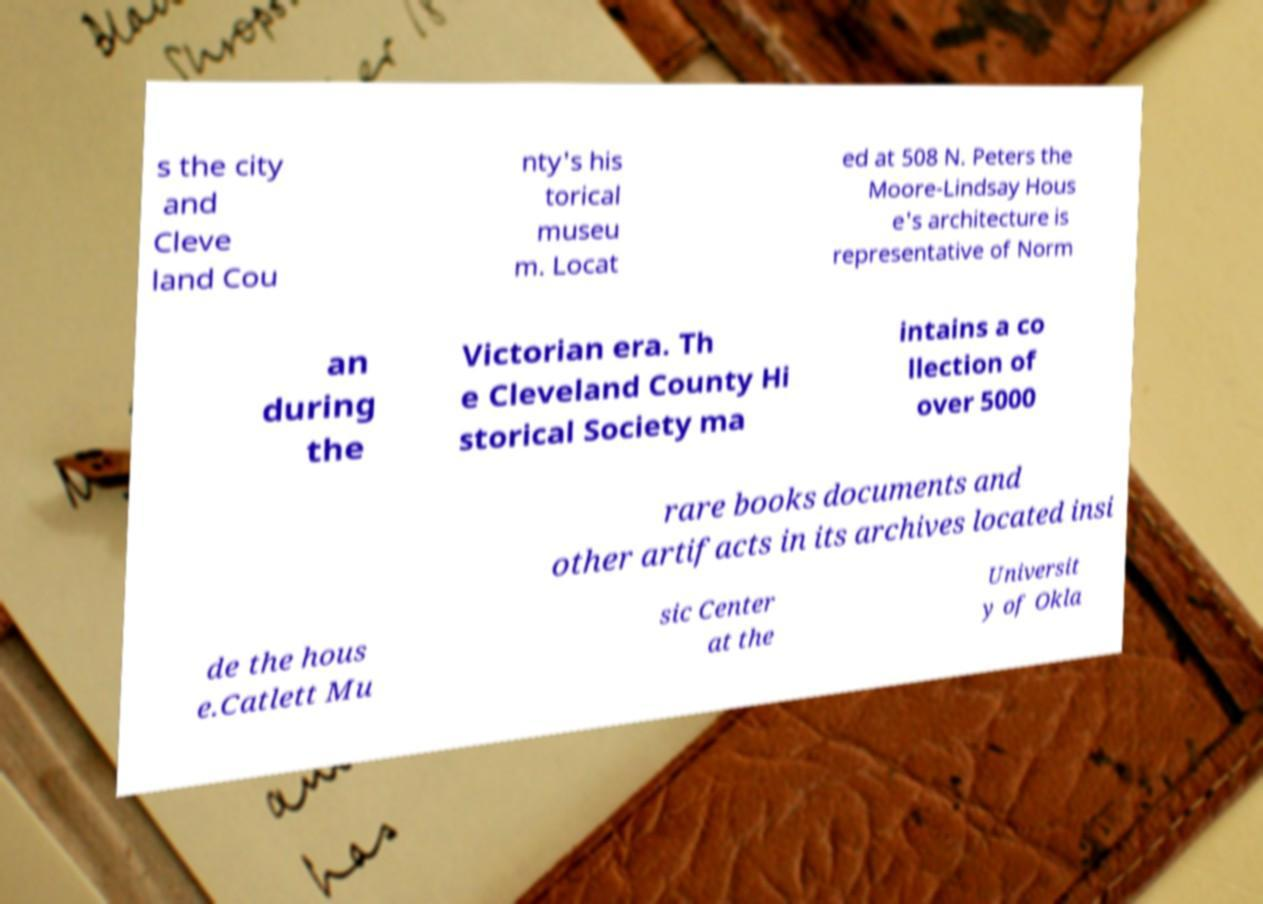Please read and relay the text visible in this image. What does it say? s the city and Cleve land Cou nty's his torical museu m. Locat ed at 508 N. Peters the Moore-Lindsay Hous e's architecture is representative of Norm an during the Victorian era. Th e Cleveland County Hi storical Society ma intains a co llection of over 5000 rare books documents and other artifacts in its archives located insi de the hous e.Catlett Mu sic Center at the Universit y of Okla 